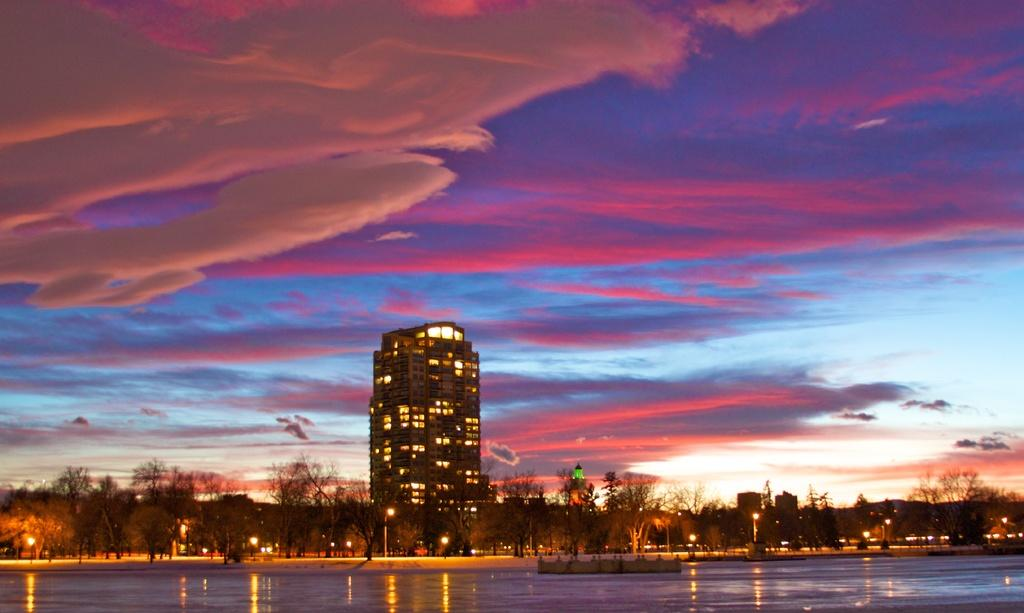What type of structures are visible in the image? There are buildings with lights in the image. What other natural elements can be seen in the image? There are trees in the image. What type of artificial lighting is present in the image? There are street lights in the image. What is visible in the sky in the image? Clouds are visible in the sky in the image. Can you see the queen wearing a quilt on her ear in the image? There is no queen or quilt on her ear present in the image. 